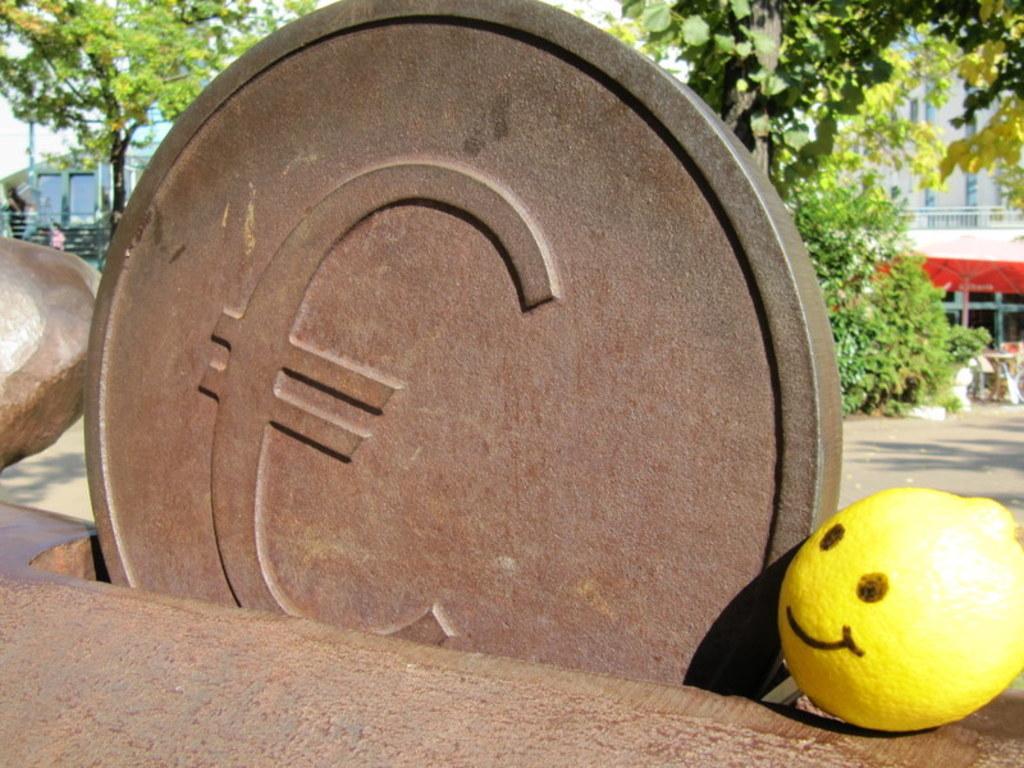Describe this image in one or two sentences. In this image, there is an outside view. There is a coin in the middle of the image made up of a stone. There is a smile in the bottom right of the image. There is a tree in the top left and in the top right of the image. 